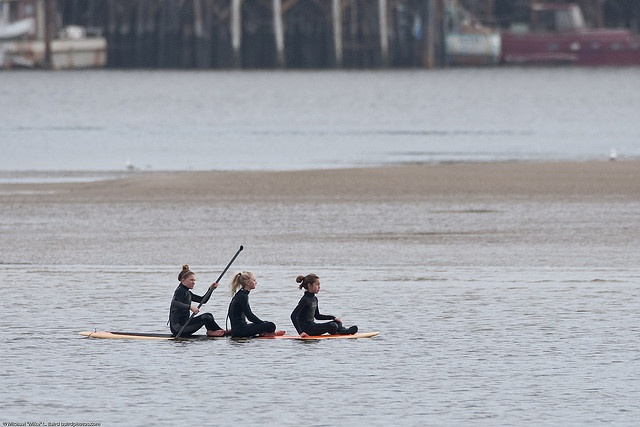Describe the objects in this image and their specific colors. I can see people in gray and black tones, people in gray, black, lightgray, and darkgray tones, surfboard in gray, black, lightgray, and darkgray tones, and people in gray, black, darkgray, and lightgray tones in this image. 